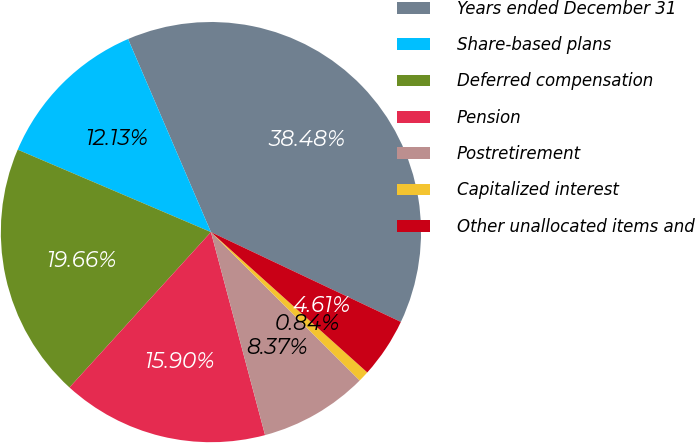<chart> <loc_0><loc_0><loc_500><loc_500><pie_chart><fcel>Years ended December 31<fcel>Share-based plans<fcel>Deferred compensation<fcel>Pension<fcel>Postretirement<fcel>Capitalized interest<fcel>Other unallocated items and<nl><fcel>38.48%<fcel>12.13%<fcel>19.66%<fcel>15.9%<fcel>8.37%<fcel>0.84%<fcel>4.61%<nl></chart> 